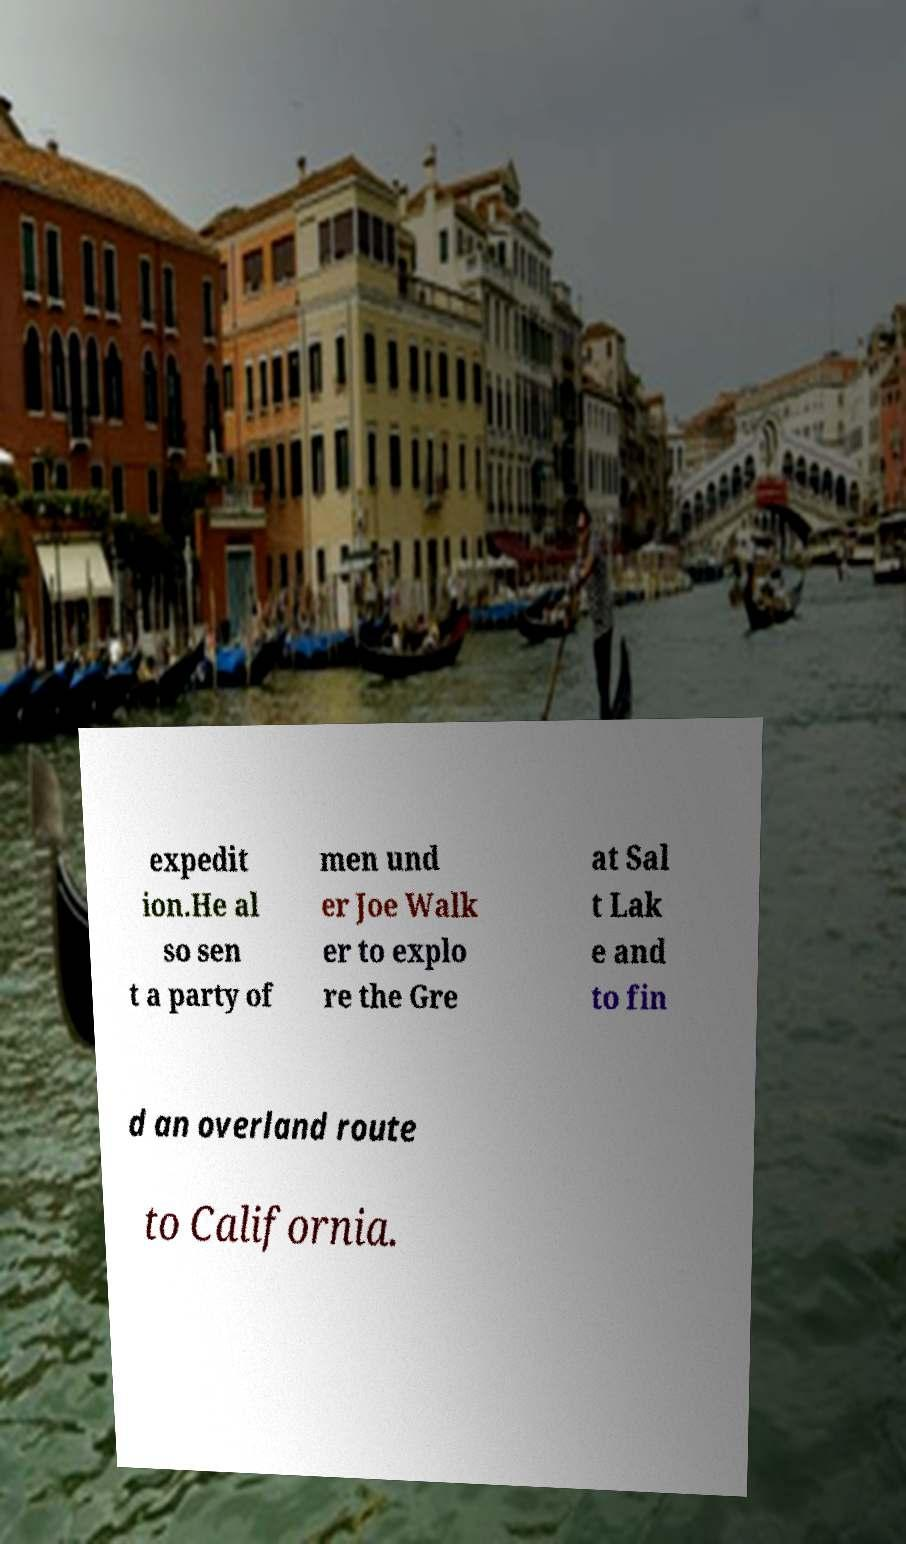Please read and relay the text visible in this image. What does it say? expedit ion.He al so sen t a party of men und er Joe Walk er to explo re the Gre at Sal t Lak e and to fin d an overland route to California. 